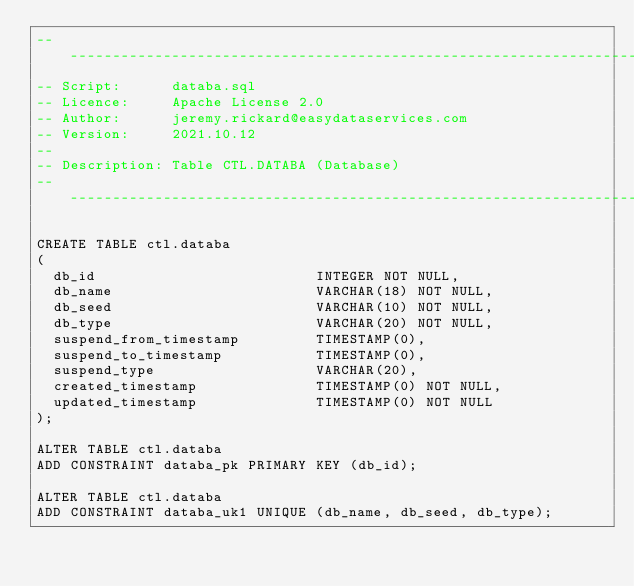Convert code to text. <code><loc_0><loc_0><loc_500><loc_500><_SQL_>--------------------------------------------------------------------------------------------------------------------------------
-- Script:      databa.sql
-- Licence:     Apache License 2.0
-- Author:      jeremy.rickard@easydataservices.com
-- Version:     2021.10.12
--
-- Description: Table CTL.DATABA (Database)
--------------------------------------------------------------------------------------------------------------------------------

CREATE TABLE ctl.databa
(
  db_id                          INTEGER NOT NULL,
  db_name                        VARCHAR(18) NOT NULL,
  db_seed                        VARCHAR(10) NOT NULL,
  db_type                        VARCHAR(20) NOT NULL,
  suspend_from_timestamp         TIMESTAMP(0),
  suspend_to_timestamp           TIMESTAMP(0),
  suspend_type                   VARCHAR(20),
  created_timestamp              TIMESTAMP(0) NOT NULL,
  updated_timestamp              TIMESTAMP(0) NOT NULL
);

ALTER TABLE ctl.databa
ADD CONSTRAINT databa_pk PRIMARY KEY (db_id);

ALTER TABLE ctl.databa
ADD CONSTRAINT databa_uk1 UNIQUE (db_name, db_seed, db_type);
</code> 